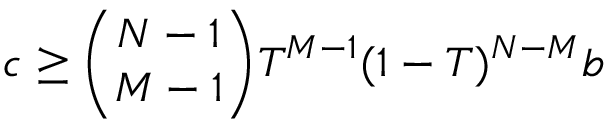Convert formula to latex. <formula><loc_0><loc_0><loc_500><loc_500>c \geq \binom { N - 1 } { M - 1 } T ^ { M - 1 } ( 1 - T ) ^ { N - M } b</formula> 